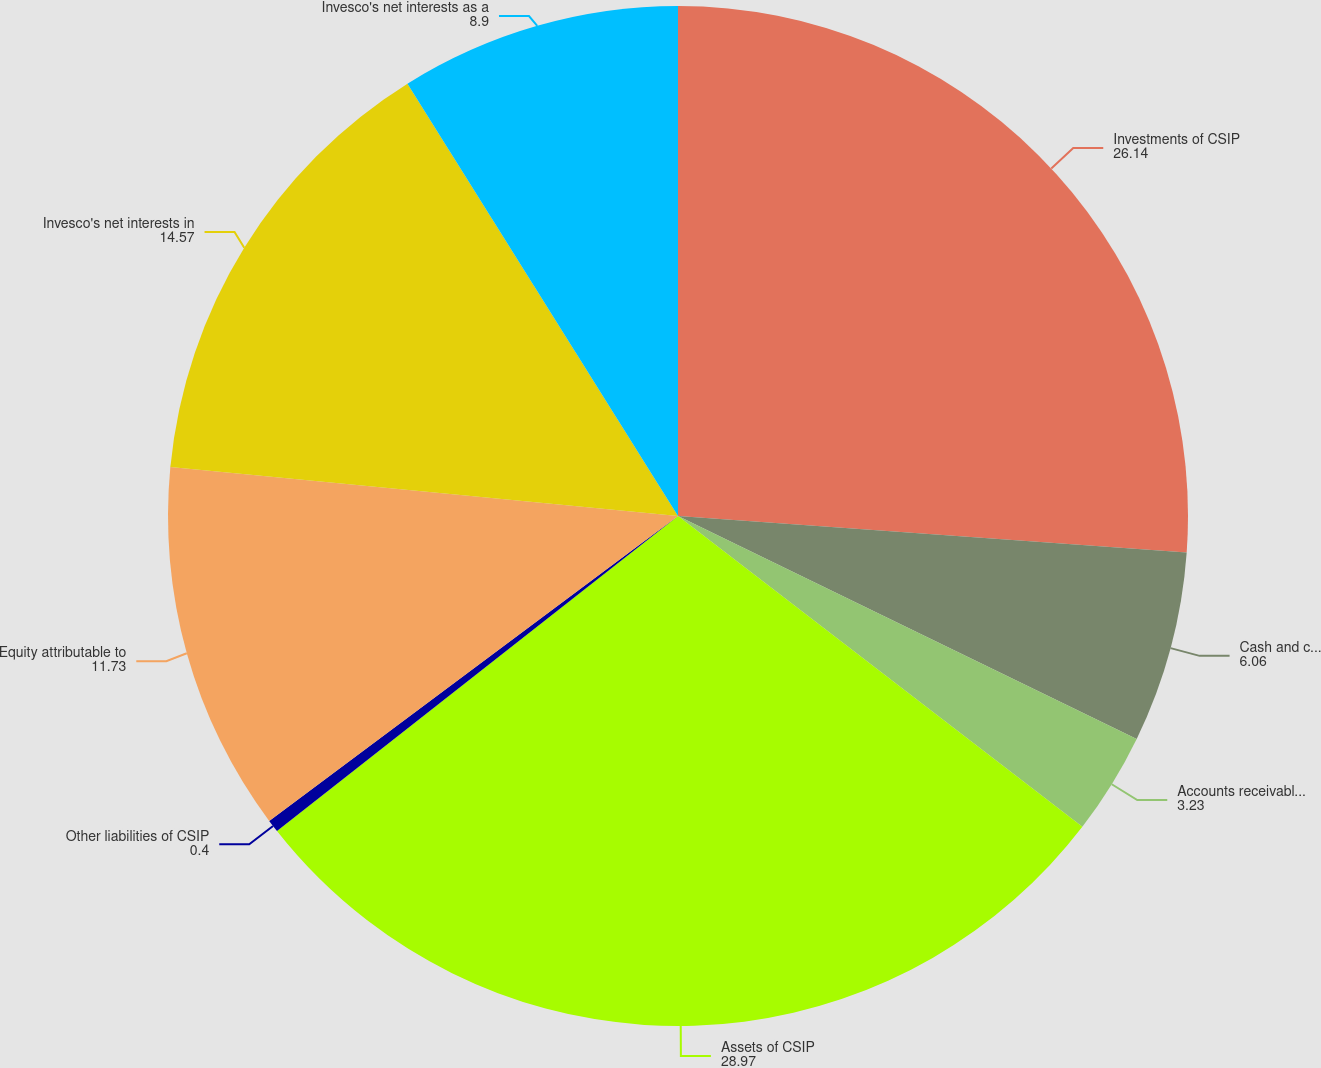Convert chart. <chart><loc_0><loc_0><loc_500><loc_500><pie_chart><fcel>Investments of CSIP<fcel>Cash and cash equivalents of<fcel>Accounts receivable and other<fcel>Assets of CSIP<fcel>Other liabilities of CSIP<fcel>Equity attributable to<fcel>Invesco's net interests in<fcel>Invesco's net interests as a<nl><fcel>26.14%<fcel>6.06%<fcel>3.23%<fcel>28.97%<fcel>0.4%<fcel>11.73%<fcel>14.57%<fcel>8.9%<nl></chart> 